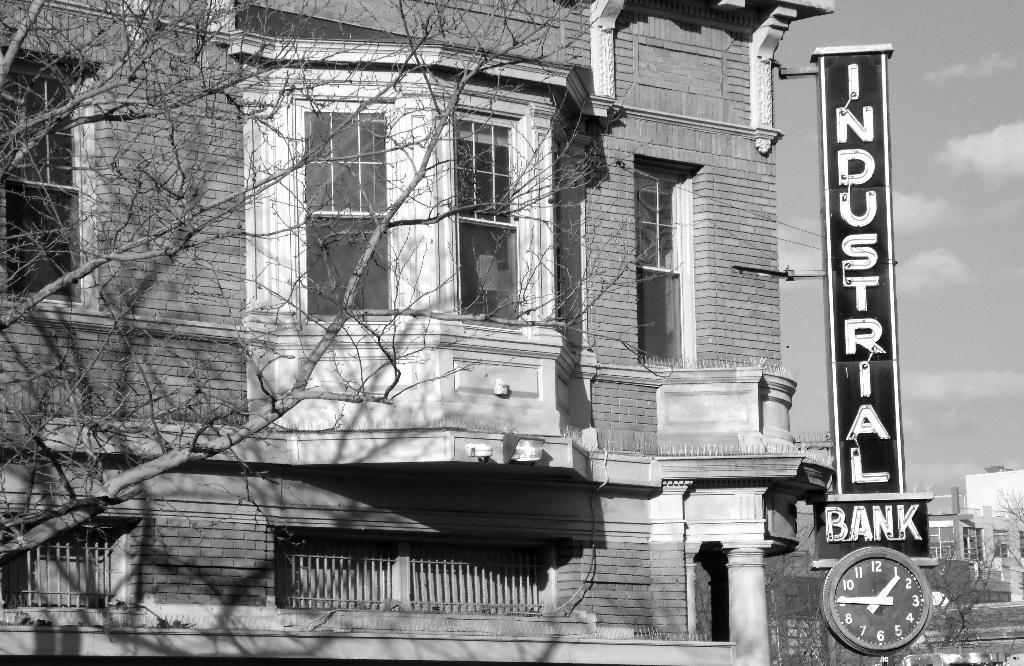What type of structures can be seen in the image? There are buildings in the image. What feature do the buildings have? The buildings have glass windows. What other elements are present in the image besides the buildings? There are trees, boards, and a clock in the image. What is the color scheme of the image? The image is in black and white. What type of rail can be seen connecting the buildings in the image? There is no rail connecting the buildings in the image; it is not mentioned in the provided facts. Who is the creator of the trees in the image? The trees in the image are natural elements and do not have a specific creator. 